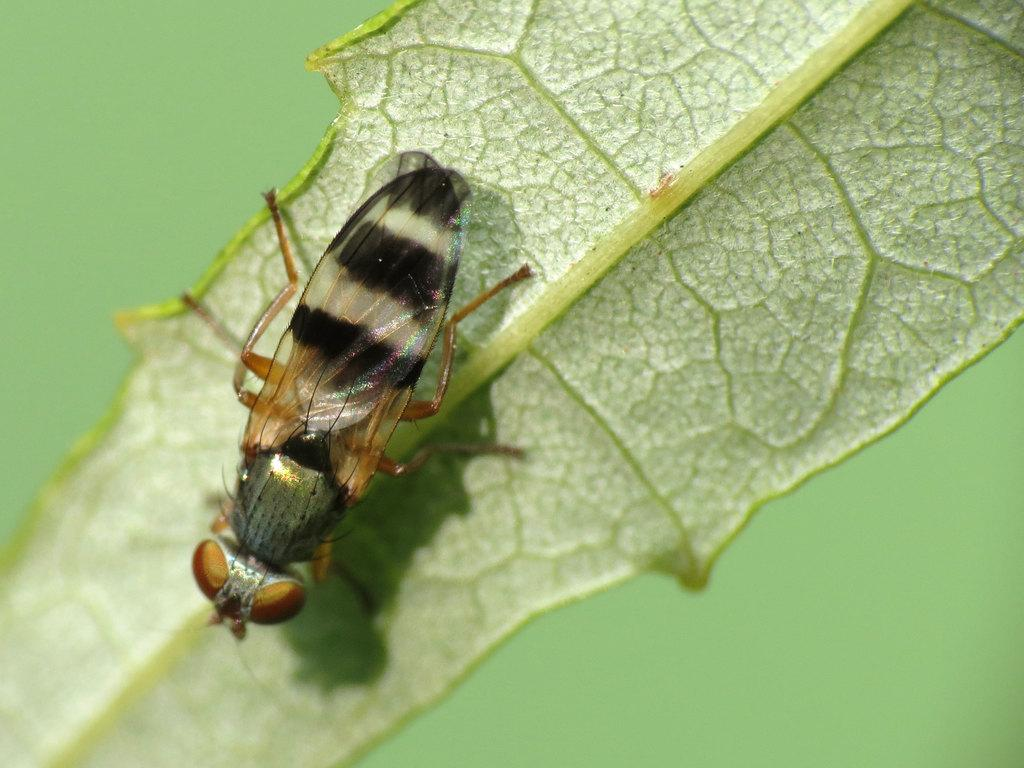What insect is present in the image? There is a hoverfly in the image. Where is the hoverfly located on the image? The hoverfly is on a leaf, and it is on the left side of the image. What can be observed about the background of the image? The background of the image is blurred. What type of wine is being served in the image? There is no wine present in the image; it features a hoverfly on a leaf. Can you describe the loaf of bread in the image? There is no loaf of bread present in the image. 